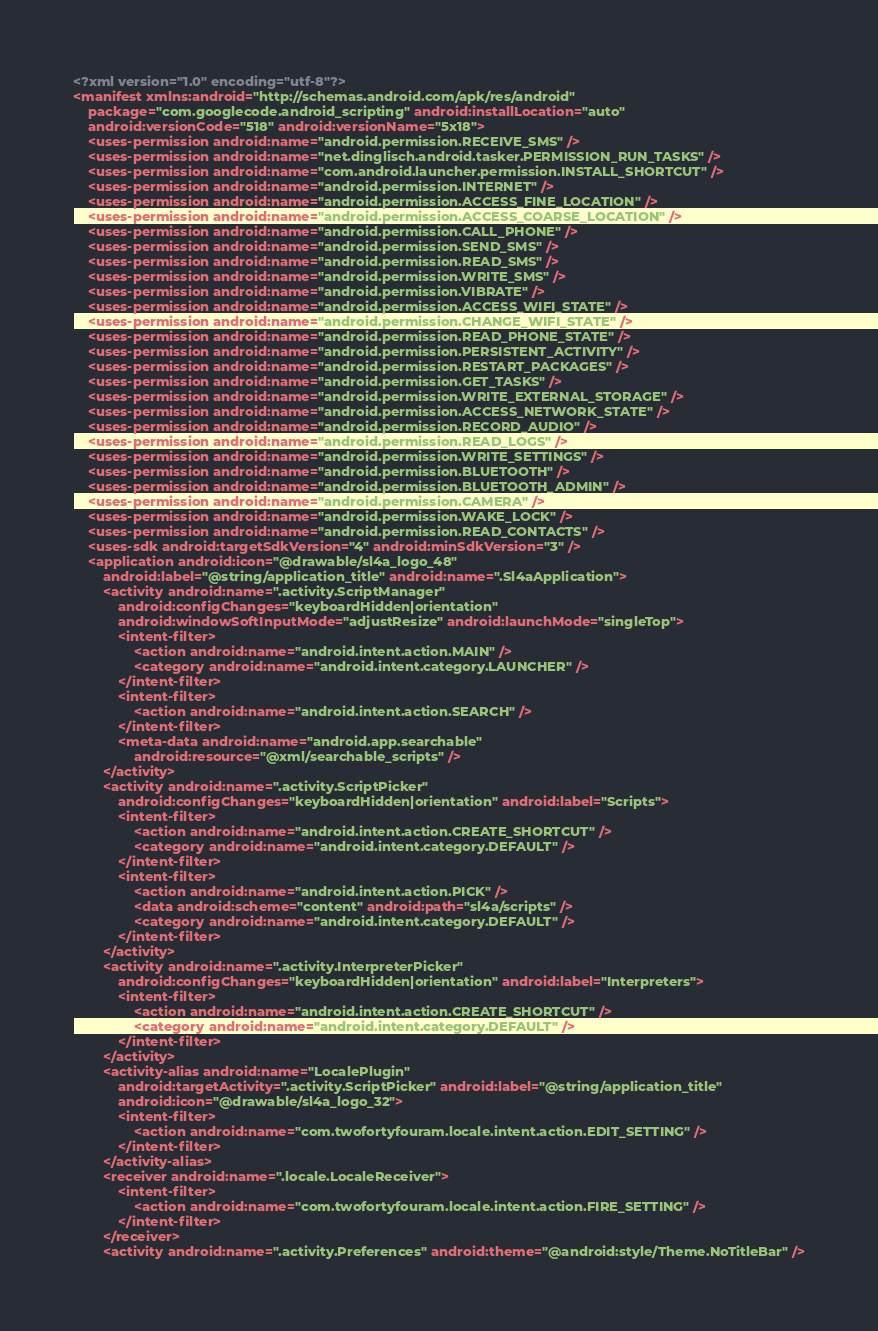<code> <loc_0><loc_0><loc_500><loc_500><_XML_><?xml version="1.0" encoding="utf-8"?>
<manifest xmlns:android="http://schemas.android.com/apk/res/android"
	package="com.googlecode.android_scripting" android:installLocation="auto"
	android:versionCode="518" android:versionName="5x18">
	<uses-permission android:name="android.permission.RECEIVE_SMS" />
	<uses-permission android:name="net.dinglisch.android.tasker.PERMISSION_RUN_TASKS" />
	<uses-permission android:name="com.android.launcher.permission.INSTALL_SHORTCUT" />
	<uses-permission android:name="android.permission.INTERNET" />
	<uses-permission android:name="android.permission.ACCESS_FINE_LOCATION" />
	<uses-permission android:name="android.permission.ACCESS_COARSE_LOCATION" />
	<uses-permission android:name="android.permission.CALL_PHONE" />
	<uses-permission android:name="android.permission.SEND_SMS" />
	<uses-permission android:name="android.permission.READ_SMS" />
	<uses-permission android:name="android.permission.WRITE_SMS" />
	<uses-permission android:name="android.permission.VIBRATE" />
	<uses-permission android:name="android.permission.ACCESS_WIFI_STATE" />
	<uses-permission android:name="android.permission.CHANGE_WIFI_STATE" />
	<uses-permission android:name="android.permission.READ_PHONE_STATE" />
	<uses-permission android:name="android.permission.PERSISTENT_ACTIVITY" />
	<uses-permission android:name="android.permission.RESTART_PACKAGES" />
	<uses-permission android:name="android.permission.GET_TASKS" />
	<uses-permission android:name="android.permission.WRITE_EXTERNAL_STORAGE" />
	<uses-permission android:name="android.permission.ACCESS_NETWORK_STATE" />
	<uses-permission android:name="android.permission.RECORD_AUDIO" />
	<uses-permission android:name="android.permission.READ_LOGS" />
	<uses-permission android:name="android.permission.WRITE_SETTINGS" />
	<uses-permission android:name="android.permission.BLUETOOTH" />
	<uses-permission android:name="android.permission.BLUETOOTH_ADMIN" />
	<uses-permission android:name="android.permission.CAMERA" />
	<uses-permission android:name="android.permission.WAKE_LOCK" />
	<uses-permission android:name="android.permission.READ_CONTACTS" />
	<uses-sdk android:targetSdkVersion="4" android:minSdkVersion="3" />
	<application android:icon="@drawable/sl4a_logo_48"
		android:label="@string/application_title" android:name=".Sl4aApplication">
		<activity android:name=".activity.ScriptManager"
			android:configChanges="keyboardHidden|orientation"
			android:windowSoftInputMode="adjustResize" android:launchMode="singleTop">
			<intent-filter>
				<action android:name="android.intent.action.MAIN" />
				<category android:name="android.intent.category.LAUNCHER" />
			</intent-filter>
			<intent-filter>
				<action android:name="android.intent.action.SEARCH" />
			</intent-filter>
			<meta-data android:name="android.app.searchable"
				android:resource="@xml/searchable_scripts" />
		</activity>
		<activity android:name=".activity.ScriptPicker"
			android:configChanges="keyboardHidden|orientation" android:label="Scripts">
			<intent-filter>
				<action android:name="android.intent.action.CREATE_SHORTCUT" />
				<category android:name="android.intent.category.DEFAULT" />
			</intent-filter>
			<intent-filter>
				<action android:name="android.intent.action.PICK" />
				<data android:scheme="content" android:path="sl4a/scripts" />
				<category android:name="android.intent.category.DEFAULT" />
			</intent-filter>
		</activity>
		<activity android:name=".activity.InterpreterPicker"
			android:configChanges="keyboardHidden|orientation" android:label="Interpreters">
			<intent-filter>
				<action android:name="android.intent.action.CREATE_SHORTCUT" />
				<category android:name="android.intent.category.DEFAULT" />
			</intent-filter>
		</activity>
		<activity-alias android:name="LocalePlugin"
			android:targetActivity=".activity.ScriptPicker" android:label="@string/application_title"
			android:icon="@drawable/sl4a_logo_32">
			<intent-filter>
				<action android:name="com.twofortyfouram.locale.intent.action.EDIT_SETTING" />
			</intent-filter>
		</activity-alias>
		<receiver android:name=".locale.LocaleReceiver">
			<intent-filter>
				<action android:name="com.twofortyfouram.locale.intent.action.FIRE_SETTING" />
			</intent-filter>
		</receiver>
		<activity android:name=".activity.Preferences" android:theme="@android:style/Theme.NoTitleBar" /></code> 